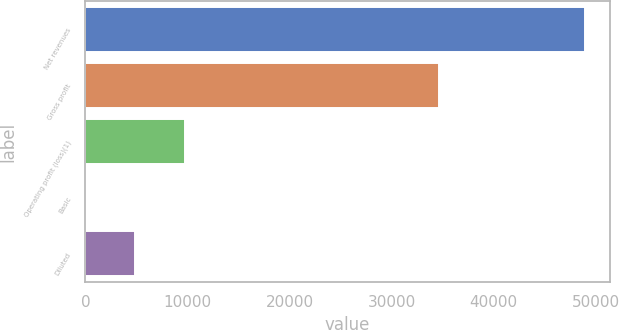Convert chart to OTSL. <chart><loc_0><loc_0><loc_500><loc_500><bar_chart><fcel>Net revenues<fcel>Gross profit<fcel>Operating profit (loss)(1)<fcel>Basic<fcel>Diluted<nl><fcel>48908<fcel>34611<fcel>9781.66<fcel>0.08<fcel>4890.87<nl></chart> 